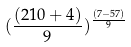Convert formula to latex. <formula><loc_0><loc_0><loc_500><loc_500>( \frac { ( 2 1 0 + 4 ) } { 9 } ) ^ { \frac { ( 7 - 5 7 ) } { 9 } }</formula> 